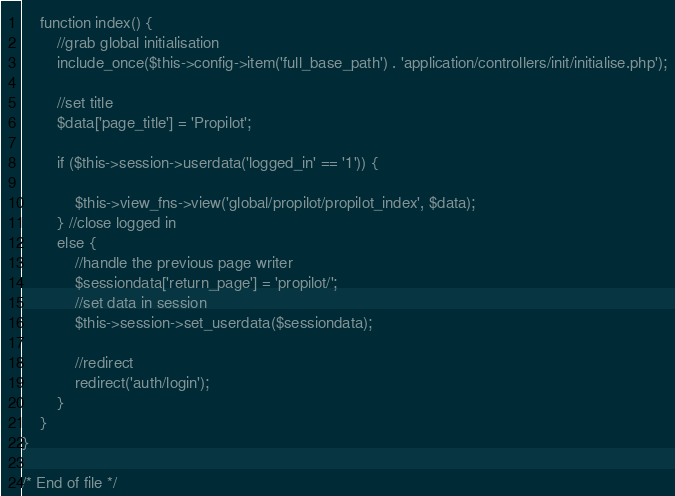<code> <loc_0><loc_0><loc_500><loc_500><_PHP_>
	function index() {
		//grab global initialisation
		include_once($this->config->item('full_base_path') . 'application/controllers/init/initialise.php');

		//set title
		$data['page_title'] = 'Propilot';

		if ($this->session->userdata('logged_in' == '1')) {

			$this->view_fns->view('global/propilot/propilot_index', $data);
		} //close logged in
		else {
			//handle the previous page writer
			$sessiondata['return_page'] = 'propilot/';
			//set data in session
			$this->session->set_userdata($sessiondata);

			//redirect
			redirect('auth/login');
		}
	}
}

/* End of file */</code> 